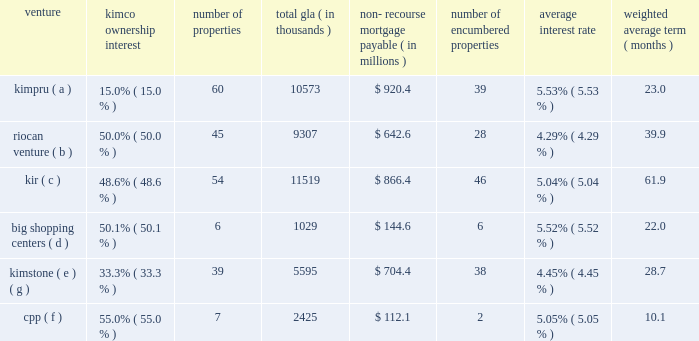Guaranteed by the company with guarantees from the joint venture partners for their proportionate amounts of any guaranty payment the company is obligated to make ( see guarantee table above ) .
Non-recourse mortgage debt is generally defined as debt whereby the lenders 2019 sole recourse with respect to borrower defaults is limited to the value of the property collateralized by the mortgage .
The lender generally does not have recourse against any other assets owned by the borrower or any of the constituent members of the borrower , except for certain specified exceptions listed in the particular loan documents ( see footnote 7 of the notes to consolidated financial statements included in this form 10-k ) .
These investments include the following joint ventures : venture ownership interest number of properties total gla thousands ) recourse mortgage payable ( in millions ) number of encumbered properties average interest weighted average ( months ) .
( a ) represents the company 2019s joint ventures with prudential real estate investors .
( b ) represents the company 2019s joint ventures with riocan real estate investment trust .
( c ) represents the company 2019s joint ventures with certain institutional investors .
( d ) represents the company 2019s remaining joint venture with big shopping centers ( tlv:big ) , an israeli public company ( see footnote 7 of the notes to consolidated financial statements included in this form 10-k ) .
( e ) represents the company 2019s joint ventures with blackstone .
( f ) represents the company 2019s joint ventures with the canadian pension plan investment board ( cppib ) .
( g ) on february 2 , 2015 , the company purchased the remaining 66.7% ( 66.7 % ) interest in the 39-property kimstone portfolio for a gross purchase price of $ 1.4 billion , including the assumption of $ 638.0 million in mortgage debt ( see footnote 26 of the notes to consolidated financial statements included in this form 10-k ) .
The company has various other unconsolidated real estate joint ventures with varying structures .
As of december 31 , 2014 , these other unconsolidated joint ventures had individual non-recourse mortgage loans aggregating $ 1.2 billion .
The aggregate debt as of december 31 , 2014 , of all of the company 2019s unconsolidated real estate joint ventures is $ 4.6 billion , of which the company 2019s proportionate share of this debt is $ 1.8 billion .
As of december 31 , 2014 , these loans had scheduled maturities ranging from one month to 19 years and bear interest at rates ranging from 1.92% ( 1.92 % ) to 8.39% ( 8.39 % ) .
Approximately $ 525.7 million of the aggregate outstanding loan balance matures in 2015 , of which the company 2019s proportionate share is $ 206.0 million .
These maturing loans are anticipated to be repaid with operating cash flows , debt refinancing and partner capital contributions , as deemed appropriate ( see footnote 7 of the notes to consolidated financial statements included in this form 10-k ) . .
As of december 31 , 2014 , what was the proportionate share of the company 2019s unconsolidated real estate joint ventures .? 
Computations: (1.8 / 4.6)
Answer: 0.3913. 